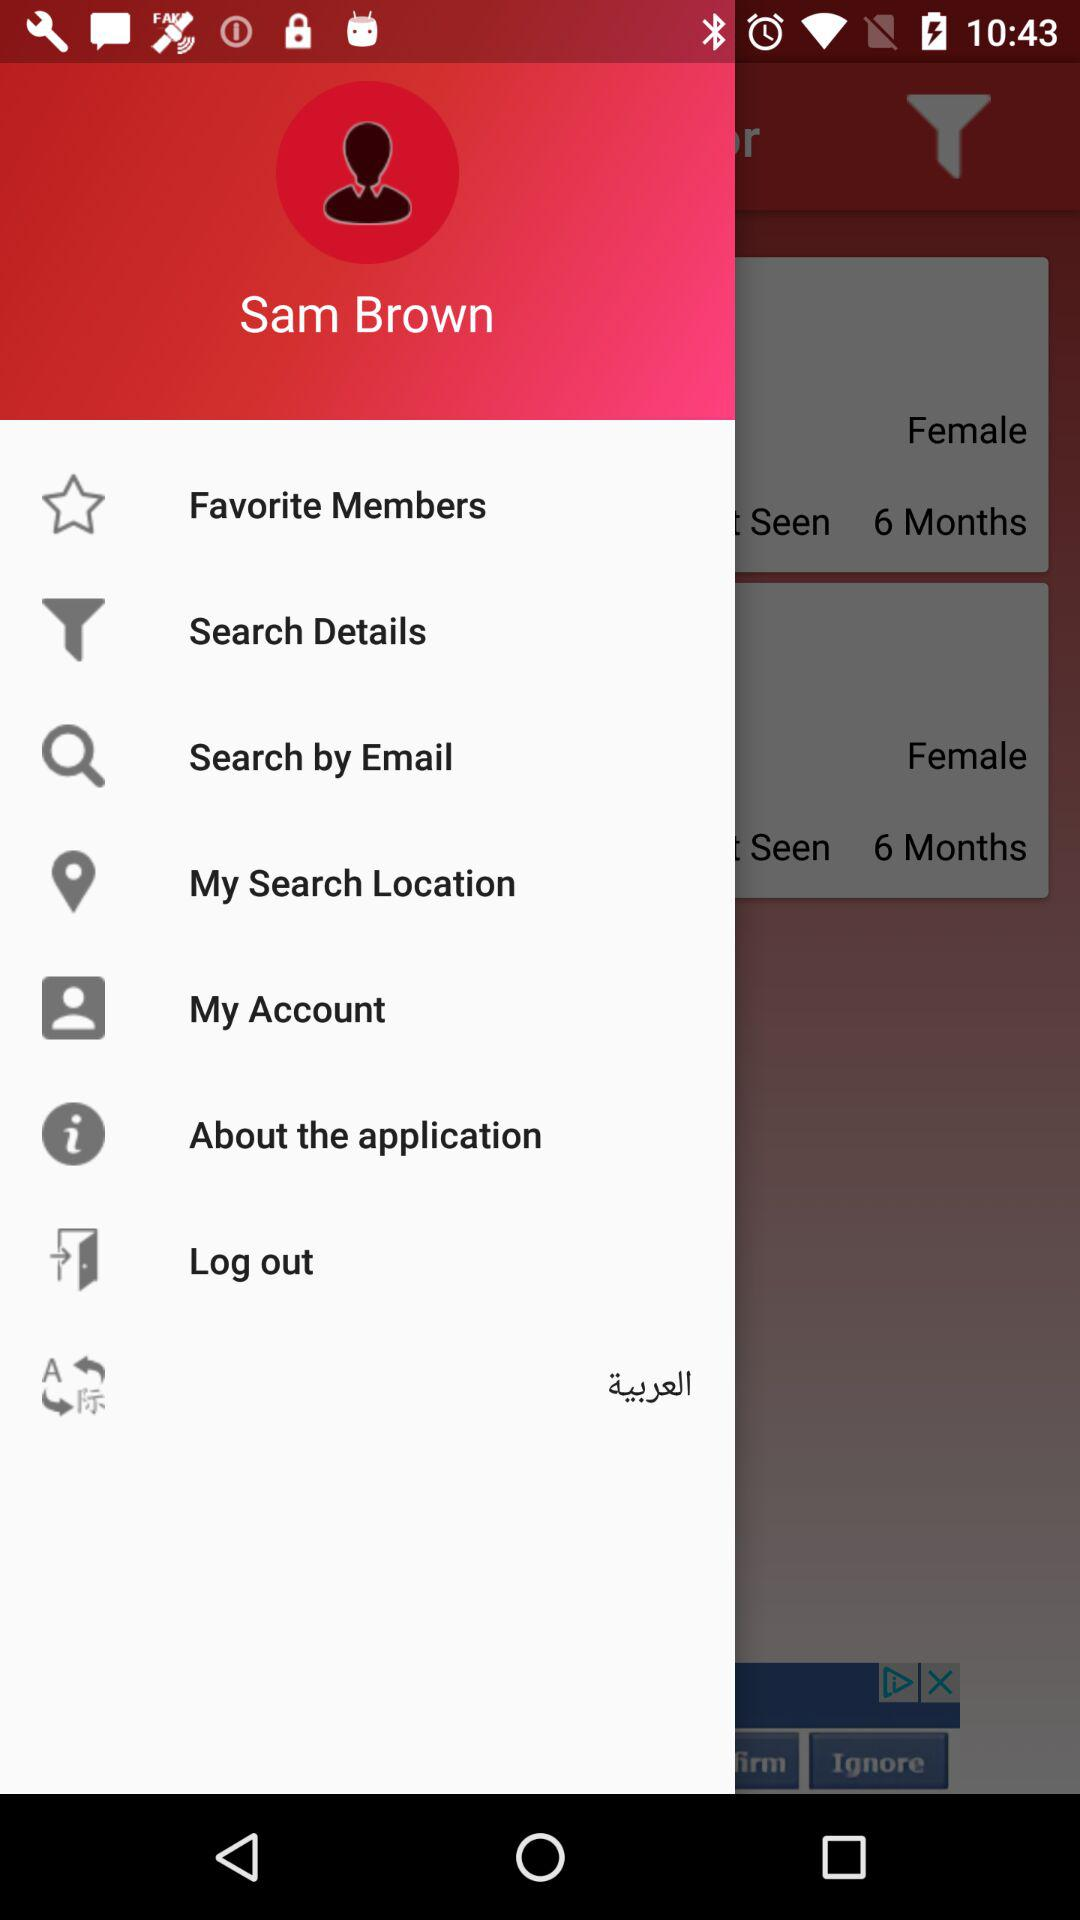What is the user's name? The user's name is Sam Brown. 